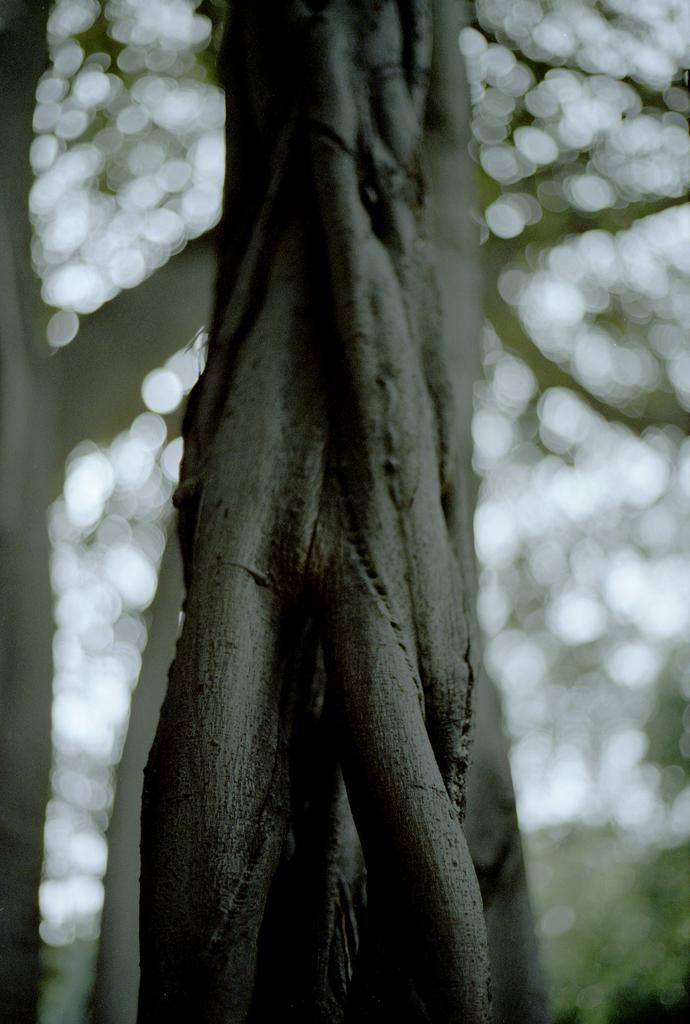Describe this image in one or two sentences. In the image we can see some trees. Background of the image is blur. 